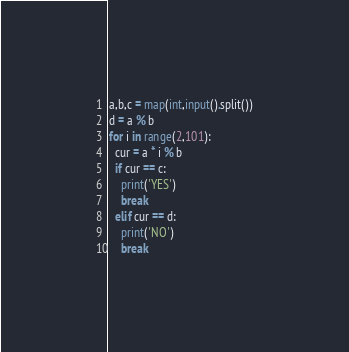Convert code to text. <code><loc_0><loc_0><loc_500><loc_500><_Python_>a,b,c = map(int,input().split())
d = a % b
for i in range(2,101):
  cur = a * i % b
  if cur == c:
    print('YES')
    break
  elif cur == d:
    print('NO')
    break</code> 